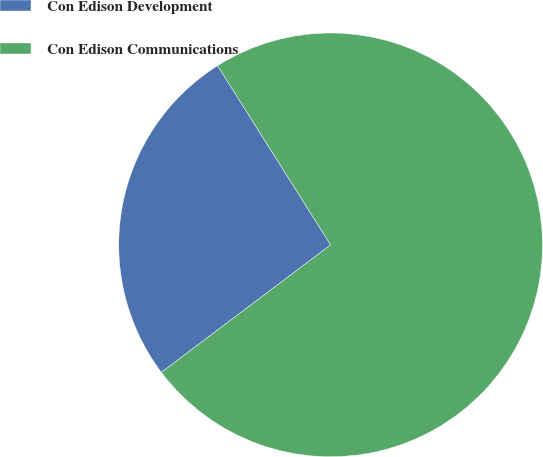Convert chart to OTSL. <chart><loc_0><loc_0><loc_500><loc_500><pie_chart><fcel>Con Edison Development<fcel>Con Edison Communications<nl><fcel>26.32%<fcel>73.68%<nl></chart> 